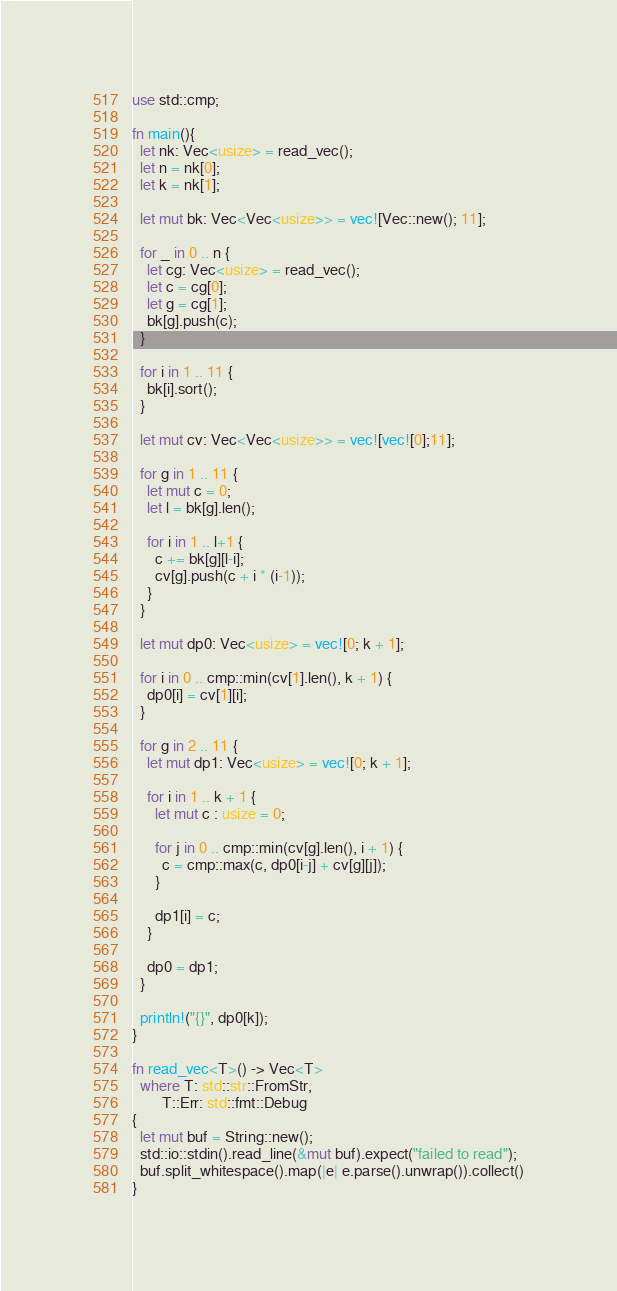<code> <loc_0><loc_0><loc_500><loc_500><_Rust_>use std::cmp;

fn main(){
  let nk: Vec<usize> = read_vec();
  let n = nk[0];
  let k = nk[1];

  let mut bk: Vec<Vec<usize>> = vec![Vec::new(); 11];

  for _ in 0 .. n {
    let cg: Vec<usize> = read_vec();
    let c = cg[0];
    let g = cg[1];
    bk[g].push(c);
  }

  for i in 1 .. 11 {
    bk[i].sort();
  }

  let mut cv: Vec<Vec<usize>> = vec![vec![0];11];

  for g in 1 .. 11 {
    let mut c = 0;
    let l = bk[g].len();
    
    for i in 1 .. l+1 {
      c += bk[g][l-i];
      cv[g].push(c + i * (i-1));
    }
  }

  let mut dp0: Vec<usize> = vec![0; k + 1];
  
  for i in 0 .. cmp::min(cv[1].len(), k + 1) {
    dp0[i] = cv[1][i];
  }
  
  for g in 2 .. 11 {
    let mut dp1: Vec<usize> = vec![0; k + 1];
    
    for i in 1 .. k + 1 {
      let mut c : usize = 0;
      
      for j in 0 .. cmp::min(cv[g].len(), i + 1) {
        c = cmp::max(c, dp0[i-j] + cv[g][j]);
      }
      
      dp1[i] = c;
    }
    
    dp0 = dp1;
  }
  
  println!("{}", dp0[k]);
}

fn read_vec<T>() -> Vec<T>
  where T: std::str::FromStr,
        T::Err: std::fmt::Debug
{
  let mut buf = String::new();
  std::io::stdin().read_line(&mut buf).expect("failed to read");
  buf.split_whitespace().map(|e| e.parse().unwrap()).collect()
}

</code> 